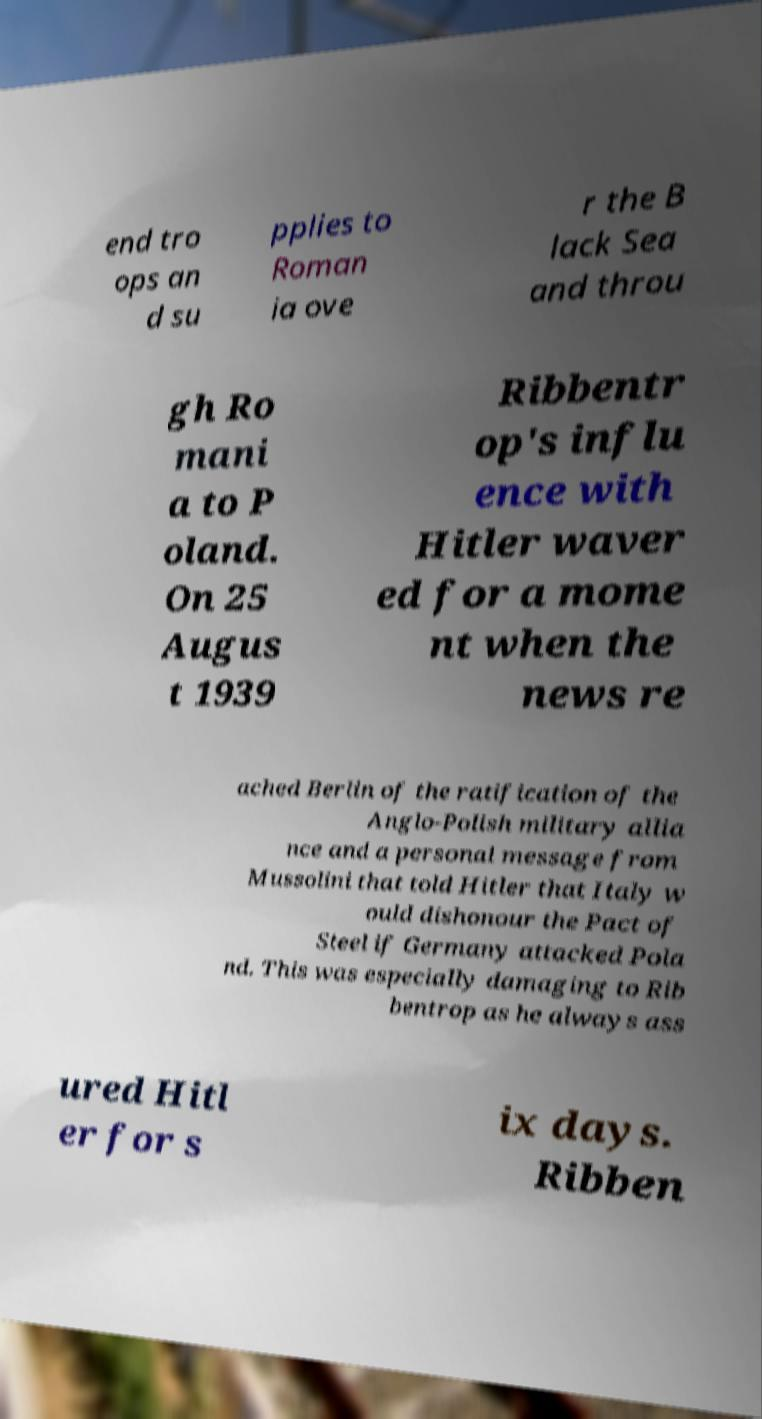Please read and relay the text visible in this image. What does it say? end tro ops an d su pplies to Roman ia ove r the B lack Sea and throu gh Ro mani a to P oland. On 25 Augus t 1939 Ribbentr op's influ ence with Hitler waver ed for a mome nt when the news re ached Berlin of the ratification of the Anglo-Polish military allia nce and a personal message from Mussolini that told Hitler that Italy w ould dishonour the Pact of Steel if Germany attacked Pola nd. This was especially damaging to Rib bentrop as he always ass ured Hitl er for s ix days. Ribben 